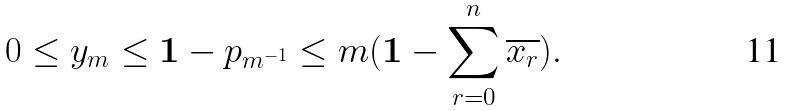<formula> <loc_0><loc_0><loc_500><loc_500>0 \leq y _ { m } \leq \mathbf 1 - p _ { m ^ { - 1 } } \leq m ( \mathbf 1 - \sum ^ { n } _ { r = 0 } \overline { x _ { r } } ) .</formula> 